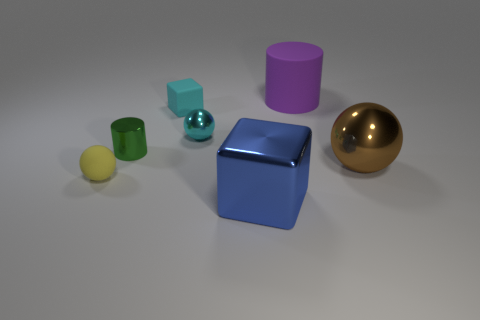Subtract all large balls. How many balls are left? 2 Subtract all brown balls. How many balls are left? 2 Subtract all cylinders. How many objects are left? 5 Add 3 red metal spheres. How many objects exist? 10 Subtract 2 cubes. How many cubes are left? 0 Subtract all yellow cylinders. Subtract all blue cubes. How many cylinders are left? 2 Subtract all gray blocks. How many yellow spheres are left? 1 Subtract all large purple rubber cylinders. Subtract all small green objects. How many objects are left? 5 Add 2 metal objects. How many metal objects are left? 6 Add 3 metallic cylinders. How many metallic cylinders exist? 4 